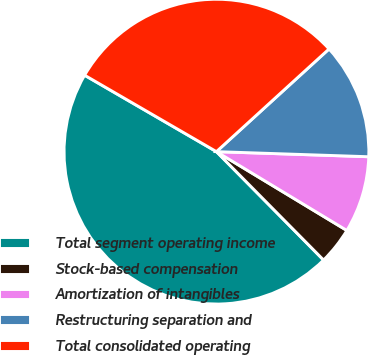Convert chart to OTSL. <chart><loc_0><loc_0><loc_500><loc_500><pie_chart><fcel>Total segment operating income<fcel>Stock-based compensation<fcel>Amortization of intangibles<fcel>Restructuring separation and<fcel>Total consolidated operating<nl><fcel>45.77%<fcel>3.94%<fcel>8.12%<fcel>12.3%<fcel>29.87%<nl></chart> 